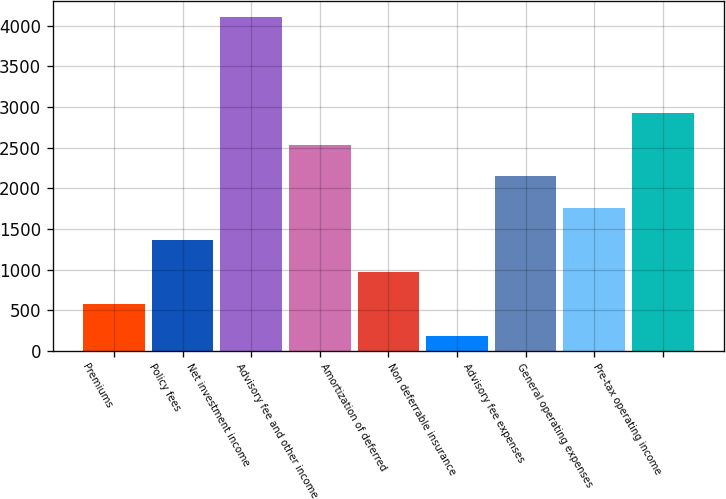<chart> <loc_0><loc_0><loc_500><loc_500><bar_chart><fcel>Premiums<fcel>Policy fees<fcel>Net investment income<fcel>Advisory fee and other income<fcel>Amortization of deferred<fcel>Non deferrable insurance<fcel>Advisory fee expenses<fcel>General operating expenses<fcel>Pre-tax operating income<nl><fcel>579.5<fcel>1362.5<fcel>4103<fcel>2537<fcel>971<fcel>188<fcel>2145.5<fcel>1754<fcel>2928.5<nl></chart> 